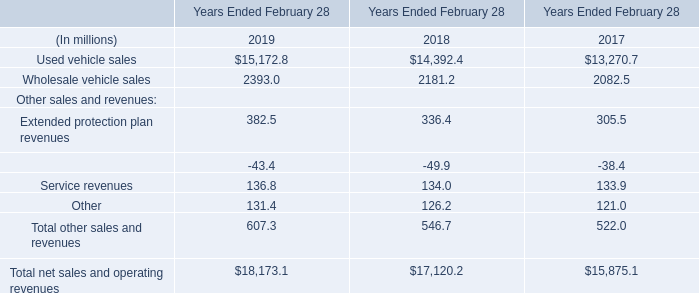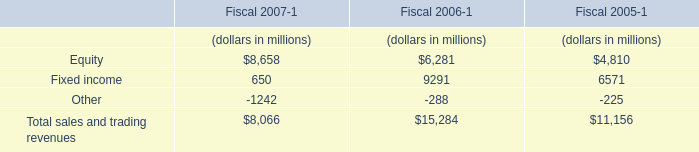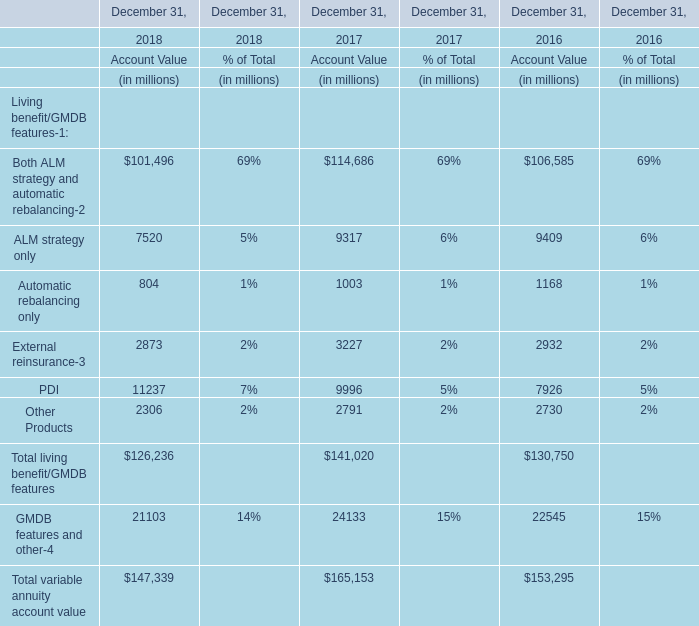What's the current growing rate of the Account Value of Other Products on December 31? 
Computations: ((2306 - 2791) / 2791)
Answer: -0.17377. 